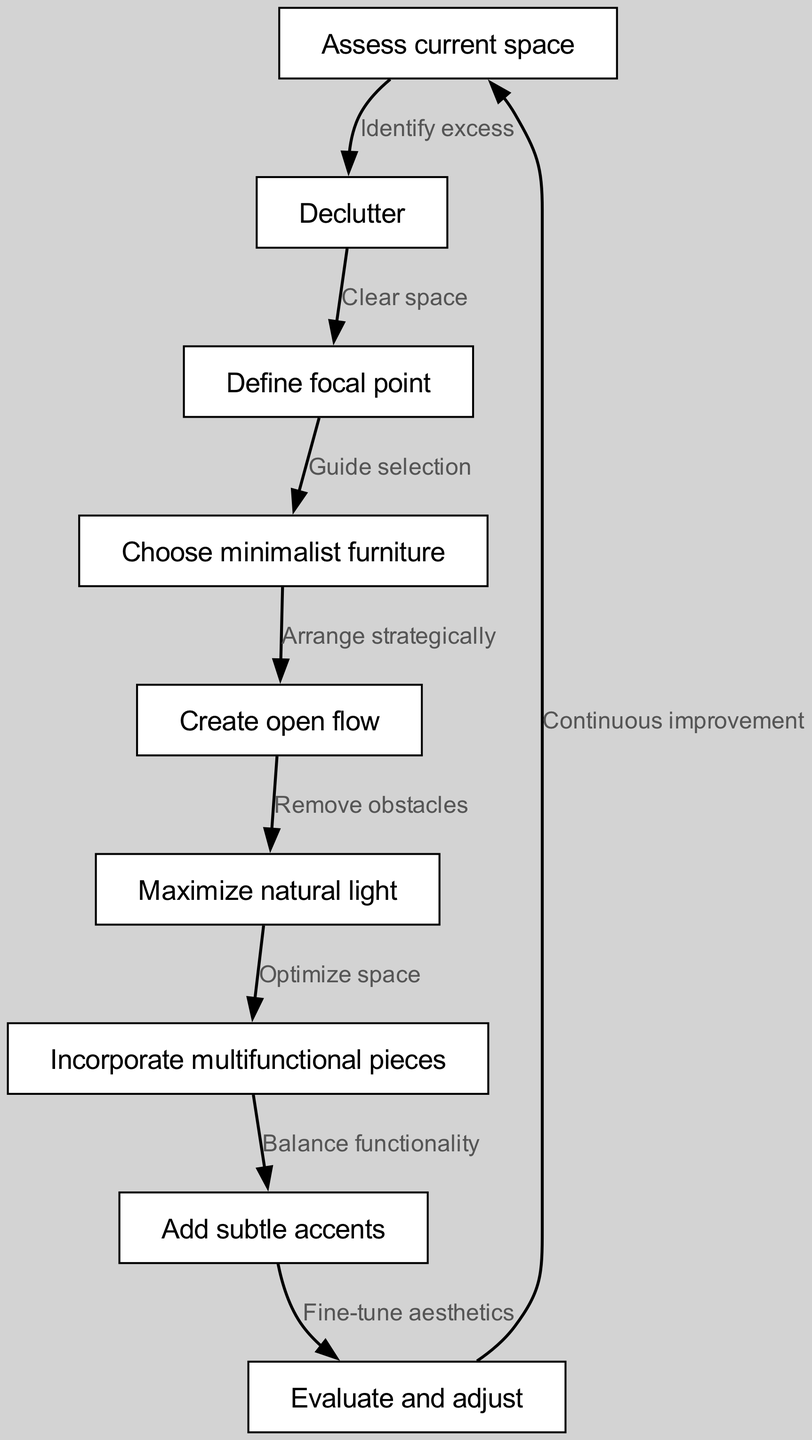What is the first step in the mindful furniture arrangement process? The first step in the directed graph is "Assess current space," as it is the starting node with no incoming edges.
Answer: Assess current space How many nodes are there in the diagram? To find the number of nodes, we can count each unique node mentioned in the provided data. There are 8 nodes listed.
Answer: 8 What directs the transition from "Define focal point" to "Choose minimalist furniture"? The edge leading from "Define focal point" to "Choose minimalist furniture" is labeled "Guide selection," indicating the reasoning for moving from focal point definition to selecting furniture.
Answer: Guide selection What is the relationship between "Create open flow" and "Maximize natural light"? The directed edge connecting "Create open flow" to "Maximize natural light" is labeled "Remove obstacles," which implies that creating an open flow is necessary to maximize natural light in the space.
Answer: Remove obstacles What process follows "Add subtle accents"? According to the directed flow, "Add subtle accents" is followed by "Evaluate and adjust," indicating that accents should be assessed afterward.
Answer: Evaluate and adjust What type of pieces are incorporated after maximizing natural light? The directed edge shows that after "Maximize natural light," the recommended action is to "Incorporate multifunctional pieces," signifying the next step in the design process.
Answer: Incorporate multifunctional pieces Which step requires evaluating and adjusting? The directed graph indicates that "Evaluate and adjust" is an action that follows after "Add subtle accents," showing where this evaluation process occurs.
Answer: Evaluate and adjust How do we continuously improve the arrangement in our space? The directed edge leads back from "Evaluate and adjust" to "Assess current space," suggesting that continuous improvement involves re-assessing the space after adjustments.
Answer: Assess current space 